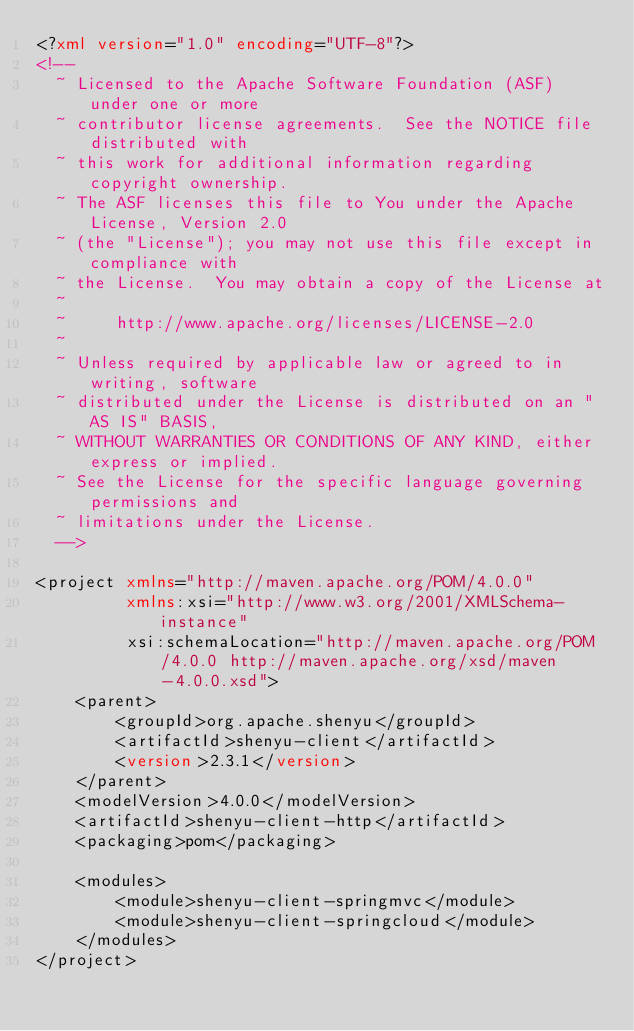Convert code to text. <code><loc_0><loc_0><loc_500><loc_500><_XML_><?xml version="1.0" encoding="UTF-8"?>
<!--
  ~ Licensed to the Apache Software Foundation (ASF) under one or more
  ~ contributor license agreements.  See the NOTICE file distributed with
  ~ this work for additional information regarding copyright ownership.
  ~ The ASF licenses this file to You under the Apache License, Version 2.0
  ~ (the "License"); you may not use this file except in compliance with
  ~ the License.  You may obtain a copy of the License at
  ~
  ~     http://www.apache.org/licenses/LICENSE-2.0
  ~
  ~ Unless required by applicable law or agreed to in writing, software
  ~ distributed under the License is distributed on an "AS IS" BASIS,
  ~ WITHOUT WARRANTIES OR CONDITIONS OF ANY KIND, either express or implied.
  ~ See the License for the specific language governing permissions and
  ~ limitations under the License.
  -->

<project xmlns="http://maven.apache.org/POM/4.0.0"
         xmlns:xsi="http://www.w3.org/2001/XMLSchema-instance"
         xsi:schemaLocation="http://maven.apache.org/POM/4.0.0 http://maven.apache.org/xsd/maven-4.0.0.xsd">
    <parent>
        <groupId>org.apache.shenyu</groupId>
        <artifactId>shenyu-client</artifactId>
        <version>2.3.1</version>
    </parent>
    <modelVersion>4.0.0</modelVersion>
    <artifactId>shenyu-client-http</artifactId>
    <packaging>pom</packaging>
    
    <modules>
        <module>shenyu-client-springmvc</module>
        <module>shenyu-client-springcloud</module>
    </modules>
</project></code> 